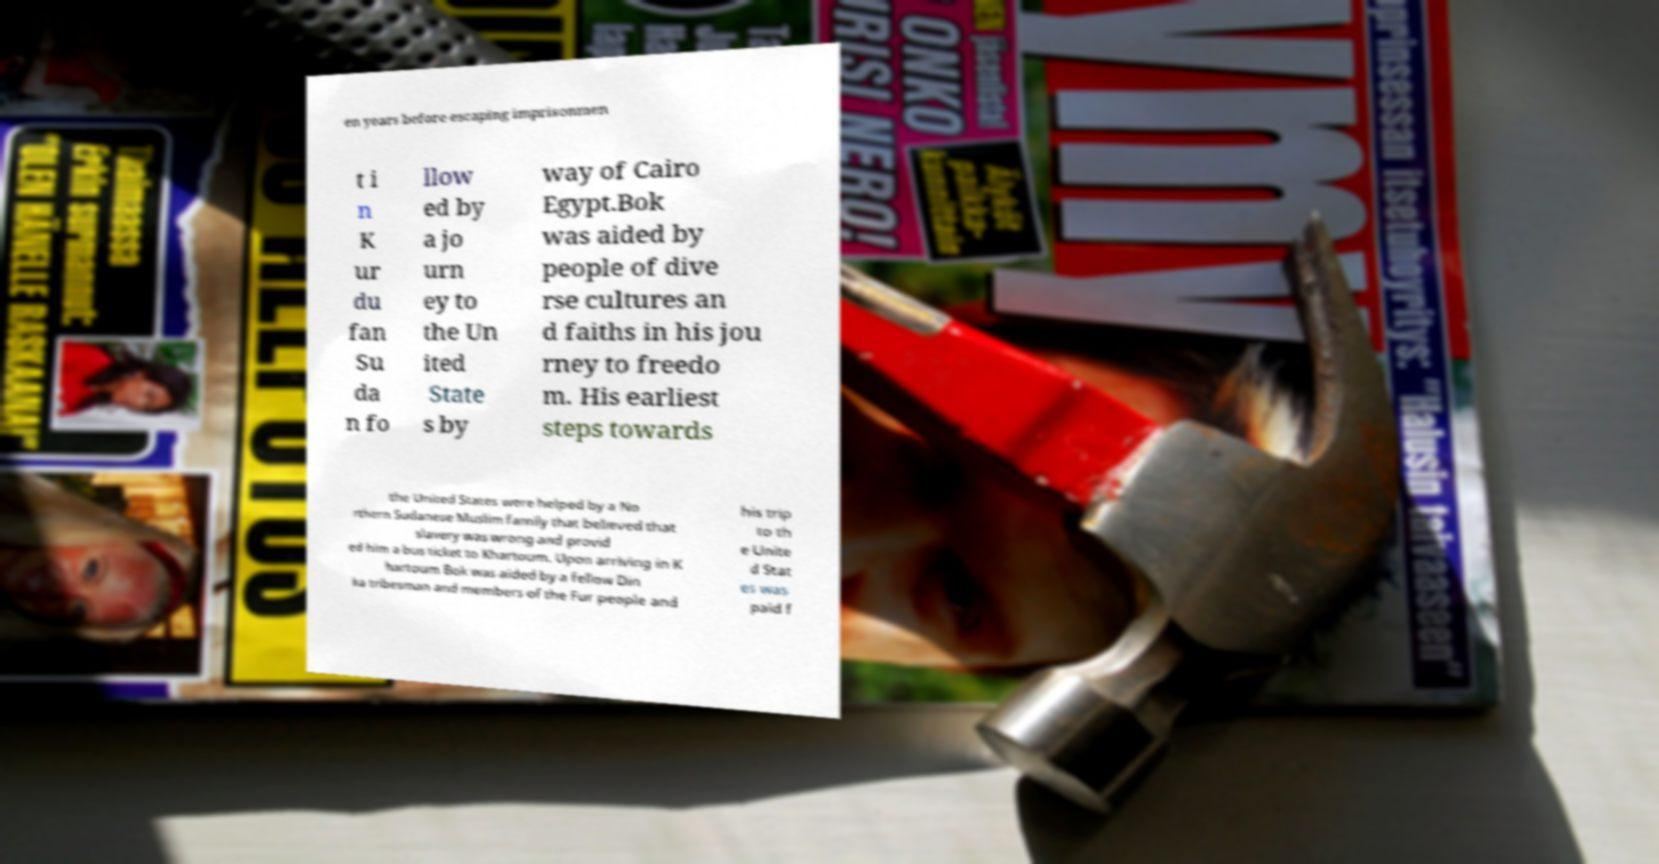Could you assist in decoding the text presented in this image and type it out clearly? en years before escaping imprisonmen t i n K ur du fan Su da n fo llow ed by a jo urn ey to the Un ited State s by way of Cairo Egypt.Bok was aided by people of dive rse cultures an d faiths in his jou rney to freedo m. His earliest steps towards the United States were helped by a No rthern Sudanese Muslim family that believed that slavery was wrong and provid ed him a bus ticket to Khartoum. Upon arriving in K hartoum Bok was aided by a fellow Din ka tribesman and members of the Fur people and his trip to th e Unite d Stat es was paid f 